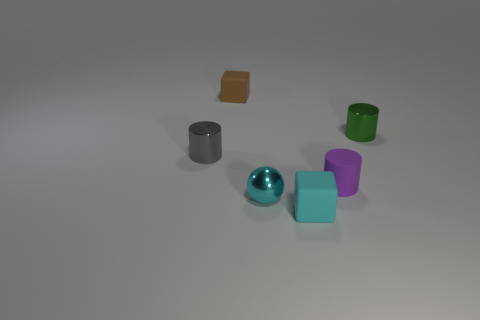Is the gray thing made of the same material as the tiny cube behind the matte cylinder?
Make the answer very short. No. What is the green cylinder that is on the right side of the cyan metal ball on the right side of the small rubber thing to the left of the small cyan rubber thing made of?
Offer a very short reply. Metal. How many brown rubber blocks are there?
Give a very brief answer. 1. What number of shiny things are either tiny yellow spheres or gray cylinders?
Offer a very short reply. 1. How many matte cubes are the same color as the small matte cylinder?
Your answer should be compact. 0. What is the small block that is left of the cyan thing on the right side of the cyan metal object made of?
Your answer should be very brief. Rubber. What number of cyan matte cylinders have the same size as the gray metallic cylinder?
Make the answer very short. 0. What number of other green objects are the same shape as the green thing?
Offer a very short reply. 0. Are there the same number of tiny cylinders in front of the cyan metal ball and green rubber blocks?
Keep it short and to the point. Yes. What is the shape of the cyan matte object that is the same size as the green object?
Provide a short and direct response. Cube. 